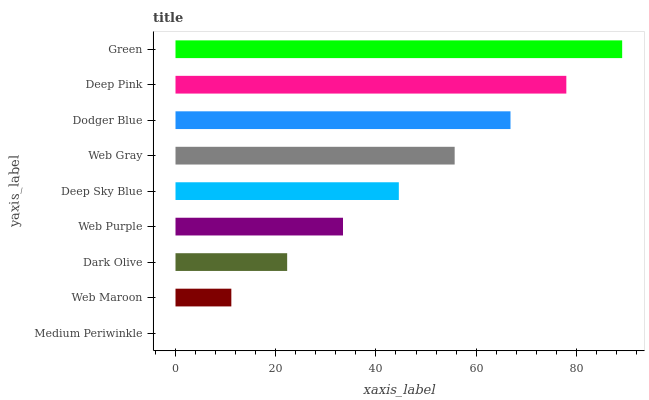Is Medium Periwinkle the minimum?
Answer yes or no. Yes. Is Green the maximum?
Answer yes or no. Yes. Is Web Maroon the minimum?
Answer yes or no. No. Is Web Maroon the maximum?
Answer yes or no. No. Is Web Maroon greater than Medium Periwinkle?
Answer yes or no. Yes. Is Medium Periwinkle less than Web Maroon?
Answer yes or no. Yes. Is Medium Periwinkle greater than Web Maroon?
Answer yes or no. No. Is Web Maroon less than Medium Periwinkle?
Answer yes or no. No. Is Deep Sky Blue the high median?
Answer yes or no. Yes. Is Deep Sky Blue the low median?
Answer yes or no. Yes. Is Dark Olive the high median?
Answer yes or no. No. Is Medium Periwinkle the low median?
Answer yes or no. No. 